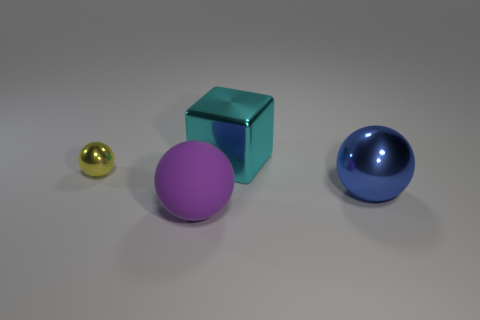Is there a yellow metallic thing of the same size as the blue ball?
Provide a short and direct response. No. There is another small metallic object that is the same shape as the purple object; what is its color?
Ensure brevity in your answer.  Yellow. Is the size of the shiny sphere behind the big metal sphere the same as the blue metal sphere that is on the right side of the metallic cube?
Make the answer very short. No. Is there another metal thing that has the same shape as the small thing?
Offer a terse response. Yes. Are there an equal number of purple rubber objects that are behind the cyan thing and brown matte cylinders?
Offer a very short reply. Yes. There is a blue sphere; is its size the same as the thing in front of the big blue object?
Make the answer very short. Yes. How many big cubes are made of the same material as the tiny sphere?
Provide a succinct answer. 1. Does the cyan cube have the same size as the blue shiny ball?
Give a very brief answer. Yes. What shape is the metal object that is on the left side of the large blue metal ball and in front of the metallic cube?
Make the answer very short. Sphere. There is a metal sphere on the left side of the matte ball; what size is it?
Make the answer very short. Small. 